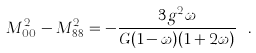Convert formula to latex. <formula><loc_0><loc_0><loc_500><loc_500>M ^ { 2 } _ { 0 0 } - M ^ { 2 } _ { 8 8 } = - \frac { 3 g ^ { 2 } \omega } { G ( 1 - \omega ) ( 1 + 2 \omega ) } \ .</formula> 